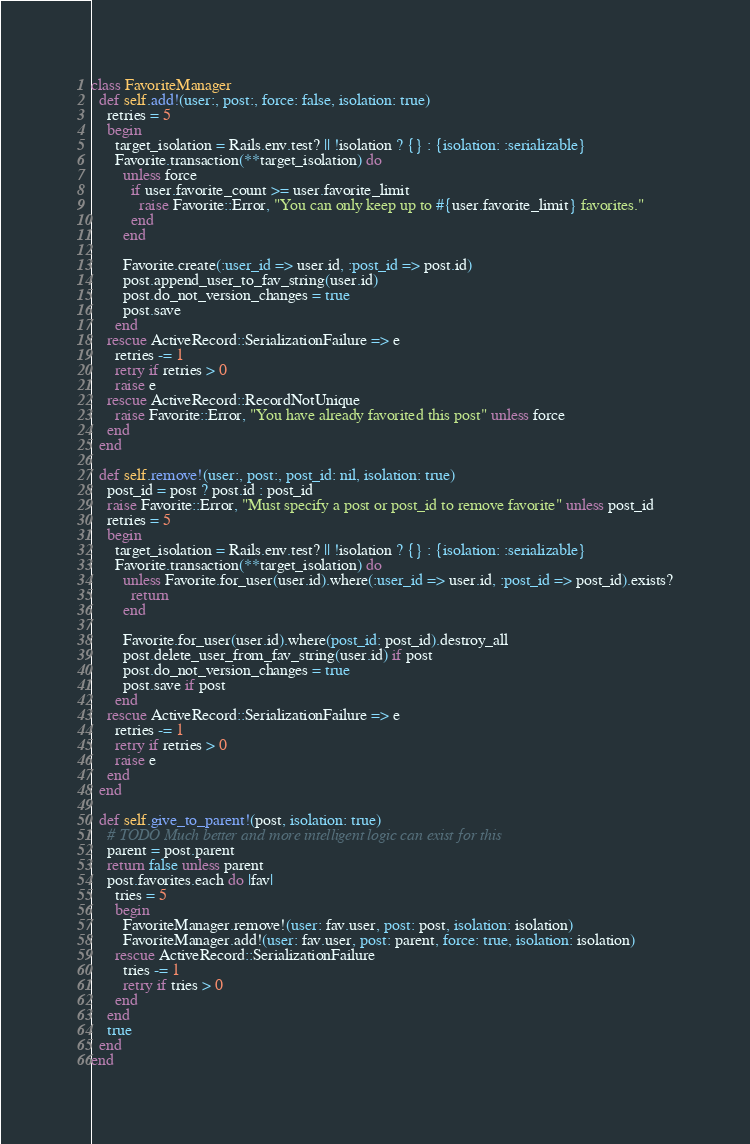Convert code to text. <code><loc_0><loc_0><loc_500><loc_500><_Ruby_>class FavoriteManager
  def self.add!(user:, post:, force: false, isolation: true)
    retries = 5
    begin
      target_isolation = Rails.env.test? || !isolation ? {} : {isolation: :serializable}
      Favorite.transaction(**target_isolation) do
        unless force
          if user.favorite_count >= user.favorite_limit
            raise Favorite::Error, "You can only keep up to #{user.favorite_limit} favorites."
          end
        end

        Favorite.create(:user_id => user.id, :post_id => post.id)
        post.append_user_to_fav_string(user.id)
        post.do_not_version_changes = true
        post.save
      end
    rescue ActiveRecord::SerializationFailure => e
      retries -= 1
      retry if retries > 0
      raise e
    rescue ActiveRecord::RecordNotUnique
      raise Favorite::Error, "You have already favorited this post" unless force
    end
  end

  def self.remove!(user:, post:, post_id: nil, isolation: true)
    post_id = post ? post.id : post_id
    raise Favorite::Error, "Must specify a post or post_id to remove favorite" unless post_id
    retries = 5
    begin
      target_isolation = Rails.env.test? || !isolation ? {} : {isolation: :serializable}
      Favorite.transaction(**target_isolation) do
        unless Favorite.for_user(user.id).where(:user_id => user.id, :post_id => post_id).exists?
          return
        end

        Favorite.for_user(user.id).where(post_id: post_id).destroy_all
        post.delete_user_from_fav_string(user.id) if post
        post.do_not_version_changes = true
        post.save if post
      end
    rescue ActiveRecord::SerializationFailure => e
      retries -= 1
      retry if retries > 0
      raise e
    end
  end

  def self.give_to_parent!(post, isolation: true)
    # TODO Much better and more intelligent logic can exist for this
    parent = post.parent
    return false unless parent
    post.favorites.each do |fav|
      tries = 5
      begin
        FavoriteManager.remove!(user: fav.user, post: post, isolation: isolation)
        FavoriteManager.add!(user: fav.user, post: parent, force: true, isolation: isolation)
      rescue ActiveRecord::SerializationFailure
        tries -= 1
        retry if tries > 0
      end
    end
    true
  end
end
</code> 